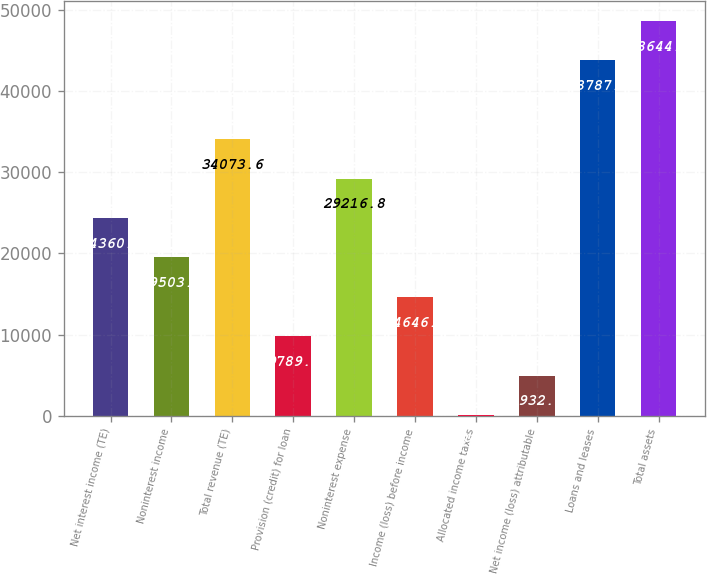<chart> <loc_0><loc_0><loc_500><loc_500><bar_chart><fcel>Net interest income (TE)<fcel>Noninterest income<fcel>Total revenue (TE)<fcel>Provision (credit) for loan<fcel>Noninterest expense<fcel>Income (loss) before income<fcel>Allocated income taxes<fcel>Net income (loss) attributable<fcel>Loans and leases<fcel>Total assets<nl><fcel>24360<fcel>19503.2<fcel>34073.6<fcel>9789.6<fcel>29216.8<fcel>14646.4<fcel>76<fcel>4932.8<fcel>43787.2<fcel>48644<nl></chart> 